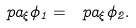<formula> <loc_0><loc_0><loc_500><loc_500>\ p a _ { \xi } \phi _ { 1 } = \ p a _ { \xi } \phi _ { 2 } .</formula> 